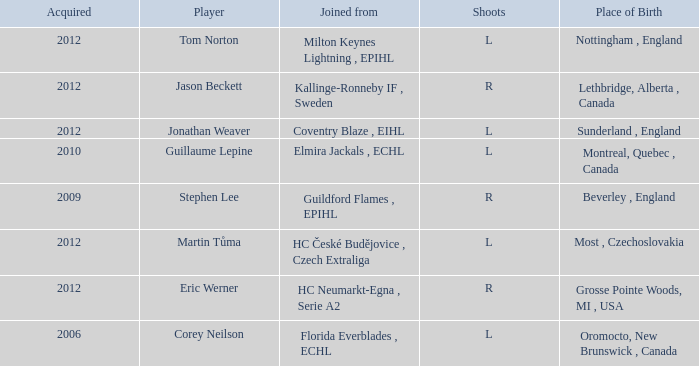Who acquired tom norton? 2012.0. 